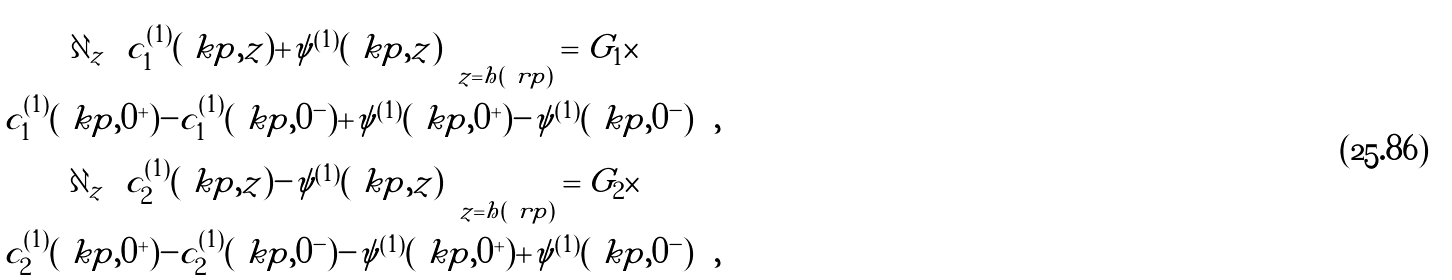<formula> <loc_0><loc_0><loc_500><loc_500>\begin{array} { c c c } \partial _ { z } \left ( c _ { 1 } ^ { ( 1 ) } ( \ k p , z ) + \psi ^ { ( 1 ) } ( \ k p , z ) \right ) _ { z = h ( \ r p ) } = G _ { 1 } \times \\ \left ( c _ { 1 } ^ { ( 1 ) } ( \ k p , 0 ^ { + } ) - c _ { 1 } ^ { ( 1 ) } ( \ k p , 0 ^ { - } ) + \psi ^ { ( 1 ) } ( \ k p , 0 ^ { + } ) - \psi ^ { ( 1 ) } ( \ k p , 0 ^ { - } ) \right ) , \\ \partial _ { z } \left ( c _ { 2 } ^ { ( 1 ) } ( \ k p , z ) - \psi ^ { ( 1 ) } ( \ k p , z ) \right ) _ { z = h ( \ r p ) } = G _ { 2 } \times \\ \left ( c _ { 2 } ^ { ( 1 ) } ( \ k p , 0 ^ { + } ) - c _ { 2 } ^ { ( 1 ) } ( \ k p , 0 ^ { - } ) - \psi ^ { ( 1 ) } ( \ k p , 0 ^ { + } ) + \psi ^ { ( 1 ) } ( \ k p , 0 ^ { - } ) \right ) , \end{array}</formula> 